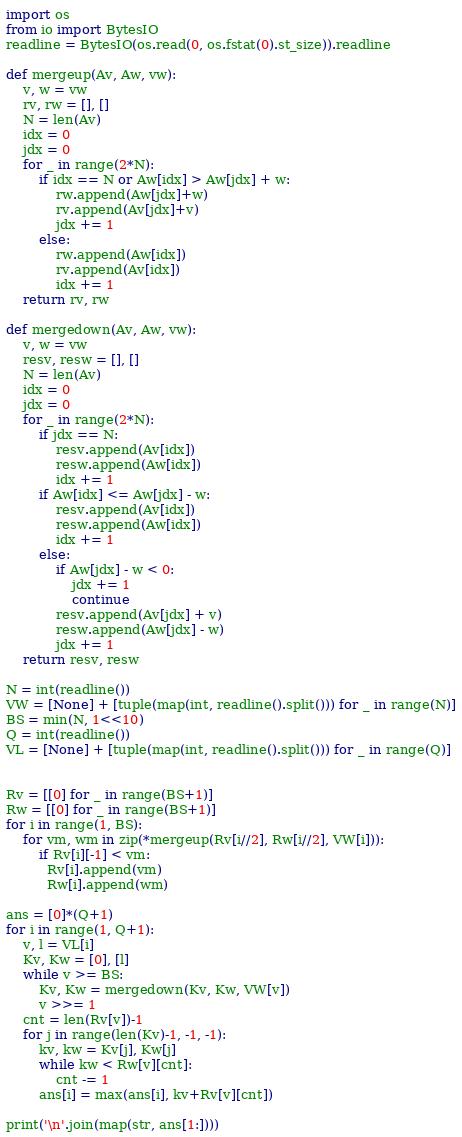<code> <loc_0><loc_0><loc_500><loc_500><_Python_>import os
from io import BytesIO
readline = BytesIO(os.read(0, os.fstat(0).st_size)).readline

def mergeup(Av, Aw, vw):
    v, w = vw
    rv, rw = [], []
    N = len(Av)
    idx = 0
    jdx = 0
    for _ in range(2*N):
        if idx == N or Aw[idx] > Aw[jdx] + w:
            rw.append(Aw[jdx]+w)
            rv.append(Av[jdx]+v)
            jdx += 1
        else:
            rw.append(Aw[idx])
            rv.append(Av[idx])
            idx += 1
    return rv, rw

def mergedown(Av, Aw, vw):
    v, w = vw
    resv, resw = [], []
    N = len(Av)
    idx = 0
    jdx = 0
    for _ in range(2*N):
        if jdx == N:
            resv.append(Av[idx])
            resw.append(Aw[idx])
            idx += 1
        if Aw[idx] <= Aw[jdx] - w:
            resv.append(Av[idx])
            resw.append(Aw[idx])
            idx += 1
        else:
            if Aw[jdx] - w < 0:
                jdx += 1
                continue
            resv.append(Av[jdx] + v)
            resw.append(Aw[jdx] - w)
            jdx += 1
    return resv, resw

N = int(readline())
VW = [None] + [tuple(map(int, readline().split())) for _ in range(N)]
BS = min(N, 1<<10)
Q = int(readline())
VL = [None] + [tuple(map(int, readline().split())) for _ in range(Q)]


Rv = [[0] for _ in range(BS+1)]
Rw = [[0] for _ in range(BS+1)]
for i in range(1, BS):
    for vm, wm in zip(*mergeup(Rv[i//2], Rw[i//2], VW[i])):
        if Rv[i][-1] < vm:
          Rv[i].append(vm)
          Rw[i].append(wm)
    
ans = [0]*(Q+1)
for i in range(1, Q+1):
    v, l = VL[i]
    Kv, Kw = [0], [l]
    while v >= BS:
        Kv, Kw = mergedown(Kv, Kw, VW[v])
        v >>= 1
    cnt = len(Rv[v])-1
    for j in range(len(Kv)-1, -1, -1):
        kv, kw = Kv[j], Kw[j]
        while kw < Rw[v][cnt]:
            cnt -= 1
        ans[i] = max(ans[i], kv+Rv[v][cnt])

print('\n'.join(map(str, ans[1:])))
</code> 